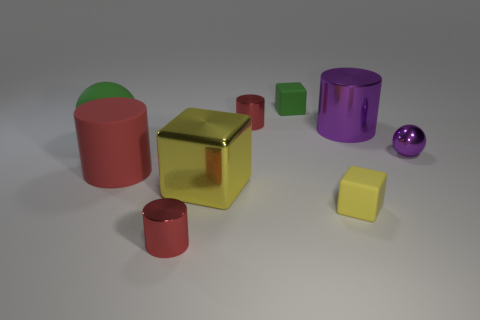Subtract all large red cylinders. How many cylinders are left? 3 Subtract all purple cylinders. How many cylinders are left? 3 Add 1 large yellow objects. How many objects exist? 10 Subtract 1 spheres. How many spheres are left? 1 Subtract all cylinders. How many objects are left? 5 Add 5 yellow blocks. How many yellow blocks are left? 7 Add 8 big balls. How many big balls exist? 9 Subtract 0 cyan spheres. How many objects are left? 9 Subtract all cyan spheres. Subtract all purple cylinders. How many spheres are left? 2 Subtract all cyan blocks. How many gray spheres are left? 0 